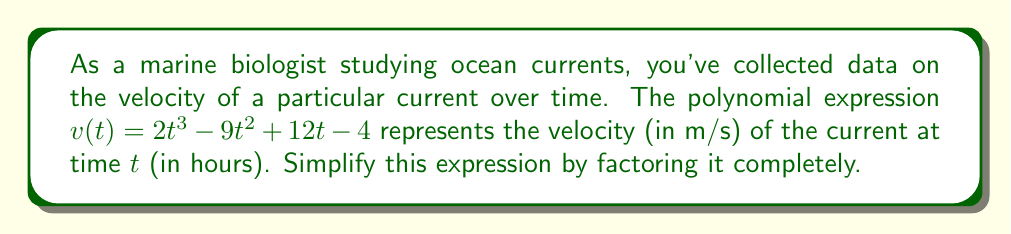Solve this math problem. To simplify this polynomial expression by factoring, we'll follow these steps:

1) First, let's check if there's a common factor for all terms:
   $v(t) = 2t^3 - 9t^2 + 12t - 4$
   There's no common factor for all terms.

2) Next, we'll try to factor by grouping:
   $v(t) = (2t^3 - 9t^2) + (12t - 4)$
   $v(t) = t^2(2t - 9) + 4(3t - 1)$

3) We can factor out $(2t - 1)$ from both groups:
   $v(t) = (2t - 1)(t^2) + (2t - 1)(2)$
   $v(t) = (2t - 1)(t^2 + 2)$

4) The factor $(t^2 + 2)$ cannot be factored further over real numbers.

Therefore, the fully factored expression is $(2t - 1)(t^2 + 2)$.
Answer: $v(t) = (2t - 1)(t^2 + 2)$ 